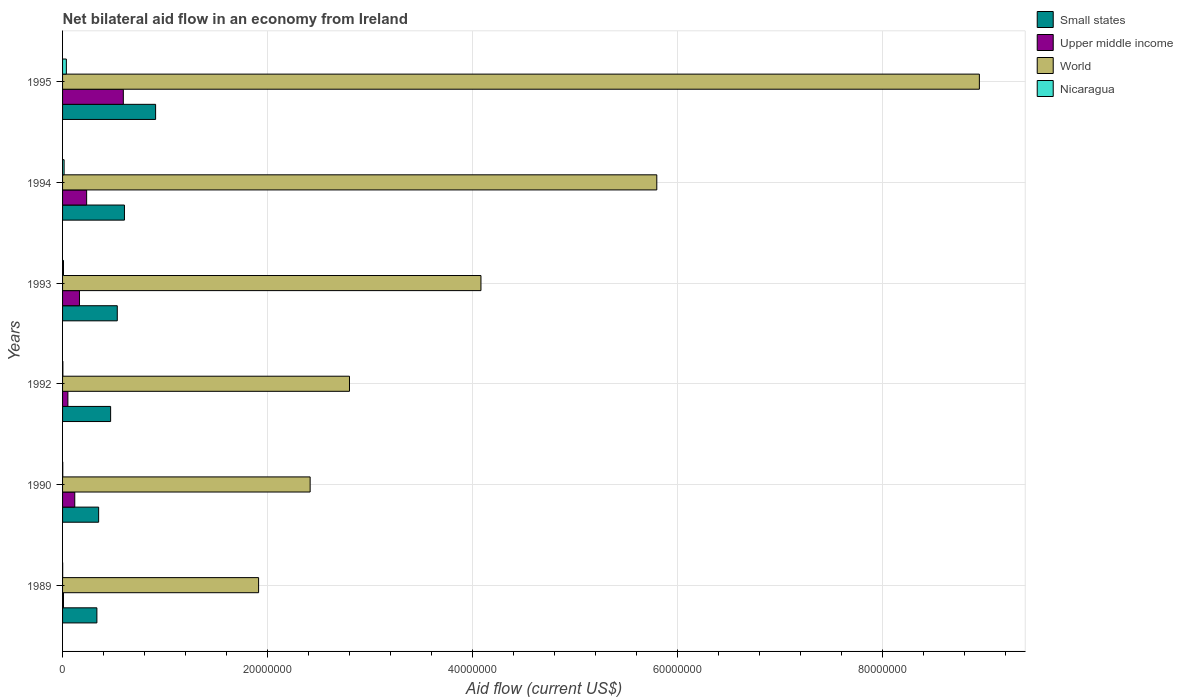Are the number of bars per tick equal to the number of legend labels?
Your answer should be very brief. Yes. Are the number of bars on each tick of the Y-axis equal?
Offer a very short reply. Yes. What is the net bilateral aid flow in Small states in 1992?
Provide a succinct answer. 4.69e+06. Across all years, what is the maximum net bilateral aid flow in Nicaragua?
Your response must be concise. 3.70e+05. Across all years, what is the minimum net bilateral aid flow in Nicaragua?
Ensure brevity in your answer.  10000. In which year was the net bilateral aid flow in Small states maximum?
Your answer should be very brief. 1995. What is the total net bilateral aid flow in World in the graph?
Provide a short and direct response. 2.60e+08. What is the difference between the net bilateral aid flow in World in 1989 and that in 1995?
Ensure brevity in your answer.  -7.03e+07. What is the difference between the net bilateral aid flow in Upper middle income in 1993 and the net bilateral aid flow in World in 1995?
Provide a succinct answer. -8.78e+07. What is the average net bilateral aid flow in Small states per year?
Ensure brevity in your answer.  5.34e+06. In the year 1989, what is the difference between the net bilateral aid flow in Upper middle income and net bilateral aid flow in Small states?
Offer a terse response. -3.26e+06. What is the ratio of the net bilateral aid flow in World in 1990 to that in 1995?
Provide a short and direct response. 0.27. Is the net bilateral aid flow in Nicaragua in 1990 less than that in 1994?
Your answer should be compact. Yes. Is the difference between the net bilateral aid flow in Upper middle income in 1992 and 1993 greater than the difference between the net bilateral aid flow in Small states in 1992 and 1993?
Your answer should be very brief. No. What is the difference between the highest and the second highest net bilateral aid flow in Small states?
Keep it short and to the point. 3.04e+06. What is the difference between the highest and the lowest net bilateral aid flow in Upper middle income?
Offer a terse response. 5.84e+06. Is the sum of the net bilateral aid flow in Small states in 1989 and 1993 greater than the maximum net bilateral aid flow in Nicaragua across all years?
Keep it short and to the point. Yes. What does the 4th bar from the top in 1989 represents?
Keep it short and to the point. Small states. What does the 2nd bar from the bottom in 1995 represents?
Offer a terse response. Upper middle income. Is it the case that in every year, the sum of the net bilateral aid flow in Nicaragua and net bilateral aid flow in Upper middle income is greater than the net bilateral aid flow in Small states?
Ensure brevity in your answer.  No. How many years are there in the graph?
Your answer should be very brief. 6. What is the difference between two consecutive major ticks on the X-axis?
Provide a succinct answer. 2.00e+07. Are the values on the major ticks of X-axis written in scientific E-notation?
Your answer should be compact. No. How are the legend labels stacked?
Offer a terse response. Vertical. What is the title of the graph?
Provide a succinct answer. Net bilateral aid flow in an economy from Ireland. Does "Nepal" appear as one of the legend labels in the graph?
Your answer should be compact. No. What is the label or title of the Y-axis?
Offer a very short reply. Years. What is the Aid flow (current US$) of Small states in 1989?
Your answer should be compact. 3.35e+06. What is the Aid flow (current US$) in Upper middle income in 1989?
Your answer should be very brief. 9.00e+04. What is the Aid flow (current US$) of World in 1989?
Your response must be concise. 1.91e+07. What is the Aid flow (current US$) of Nicaragua in 1989?
Provide a short and direct response. 10000. What is the Aid flow (current US$) of Small states in 1990?
Provide a succinct answer. 3.52e+06. What is the Aid flow (current US$) in Upper middle income in 1990?
Your answer should be very brief. 1.19e+06. What is the Aid flow (current US$) of World in 1990?
Your response must be concise. 2.42e+07. What is the Aid flow (current US$) of Nicaragua in 1990?
Offer a very short reply. 2.00e+04. What is the Aid flow (current US$) in Small states in 1992?
Your response must be concise. 4.69e+06. What is the Aid flow (current US$) of Upper middle income in 1992?
Ensure brevity in your answer.  5.20e+05. What is the Aid flow (current US$) of World in 1992?
Offer a terse response. 2.80e+07. What is the Aid flow (current US$) of Small states in 1993?
Offer a terse response. 5.34e+06. What is the Aid flow (current US$) in Upper middle income in 1993?
Offer a terse response. 1.65e+06. What is the Aid flow (current US$) of World in 1993?
Offer a terse response. 4.08e+07. What is the Aid flow (current US$) of Nicaragua in 1993?
Provide a short and direct response. 9.00e+04. What is the Aid flow (current US$) of Small states in 1994?
Offer a terse response. 6.04e+06. What is the Aid flow (current US$) in Upper middle income in 1994?
Offer a terse response. 2.35e+06. What is the Aid flow (current US$) in World in 1994?
Provide a succinct answer. 5.80e+07. What is the Aid flow (current US$) of Small states in 1995?
Provide a succinct answer. 9.08e+06. What is the Aid flow (current US$) in Upper middle income in 1995?
Your answer should be very brief. 5.93e+06. What is the Aid flow (current US$) of World in 1995?
Ensure brevity in your answer.  8.95e+07. What is the Aid flow (current US$) of Nicaragua in 1995?
Ensure brevity in your answer.  3.70e+05. Across all years, what is the maximum Aid flow (current US$) of Small states?
Provide a succinct answer. 9.08e+06. Across all years, what is the maximum Aid flow (current US$) of Upper middle income?
Provide a succinct answer. 5.93e+06. Across all years, what is the maximum Aid flow (current US$) of World?
Offer a terse response. 8.95e+07. Across all years, what is the maximum Aid flow (current US$) in Nicaragua?
Make the answer very short. 3.70e+05. Across all years, what is the minimum Aid flow (current US$) in Small states?
Keep it short and to the point. 3.35e+06. Across all years, what is the minimum Aid flow (current US$) in Upper middle income?
Ensure brevity in your answer.  9.00e+04. Across all years, what is the minimum Aid flow (current US$) in World?
Offer a terse response. 1.91e+07. What is the total Aid flow (current US$) in Small states in the graph?
Your answer should be very brief. 3.20e+07. What is the total Aid flow (current US$) of Upper middle income in the graph?
Offer a terse response. 1.17e+07. What is the total Aid flow (current US$) of World in the graph?
Provide a succinct answer. 2.60e+08. What is the total Aid flow (current US$) in Nicaragua in the graph?
Offer a very short reply. 6.70e+05. What is the difference between the Aid flow (current US$) of Small states in 1989 and that in 1990?
Offer a terse response. -1.70e+05. What is the difference between the Aid flow (current US$) in Upper middle income in 1989 and that in 1990?
Give a very brief answer. -1.10e+06. What is the difference between the Aid flow (current US$) in World in 1989 and that in 1990?
Give a very brief answer. -5.03e+06. What is the difference between the Aid flow (current US$) in Nicaragua in 1989 and that in 1990?
Offer a very short reply. -10000. What is the difference between the Aid flow (current US$) in Small states in 1989 and that in 1992?
Offer a terse response. -1.34e+06. What is the difference between the Aid flow (current US$) in Upper middle income in 1989 and that in 1992?
Provide a short and direct response. -4.30e+05. What is the difference between the Aid flow (current US$) of World in 1989 and that in 1992?
Provide a short and direct response. -8.87e+06. What is the difference between the Aid flow (current US$) in Nicaragua in 1989 and that in 1992?
Your answer should be compact. -2.00e+04. What is the difference between the Aid flow (current US$) of Small states in 1989 and that in 1993?
Provide a succinct answer. -1.99e+06. What is the difference between the Aid flow (current US$) of Upper middle income in 1989 and that in 1993?
Offer a terse response. -1.56e+06. What is the difference between the Aid flow (current US$) in World in 1989 and that in 1993?
Your answer should be compact. -2.17e+07. What is the difference between the Aid flow (current US$) in Small states in 1989 and that in 1994?
Provide a succinct answer. -2.69e+06. What is the difference between the Aid flow (current US$) of Upper middle income in 1989 and that in 1994?
Give a very brief answer. -2.26e+06. What is the difference between the Aid flow (current US$) in World in 1989 and that in 1994?
Your response must be concise. -3.89e+07. What is the difference between the Aid flow (current US$) of Nicaragua in 1989 and that in 1994?
Provide a short and direct response. -1.40e+05. What is the difference between the Aid flow (current US$) in Small states in 1989 and that in 1995?
Your answer should be compact. -5.73e+06. What is the difference between the Aid flow (current US$) in Upper middle income in 1989 and that in 1995?
Make the answer very short. -5.84e+06. What is the difference between the Aid flow (current US$) of World in 1989 and that in 1995?
Ensure brevity in your answer.  -7.03e+07. What is the difference between the Aid flow (current US$) in Nicaragua in 1989 and that in 1995?
Make the answer very short. -3.60e+05. What is the difference between the Aid flow (current US$) of Small states in 1990 and that in 1992?
Your answer should be very brief. -1.17e+06. What is the difference between the Aid flow (current US$) in Upper middle income in 1990 and that in 1992?
Give a very brief answer. 6.70e+05. What is the difference between the Aid flow (current US$) of World in 1990 and that in 1992?
Make the answer very short. -3.84e+06. What is the difference between the Aid flow (current US$) in Nicaragua in 1990 and that in 1992?
Your answer should be compact. -10000. What is the difference between the Aid flow (current US$) in Small states in 1990 and that in 1993?
Ensure brevity in your answer.  -1.82e+06. What is the difference between the Aid flow (current US$) of Upper middle income in 1990 and that in 1993?
Provide a succinct answer. -4.60e+05. What is the difference between the Aid flow (current US$) of World in 1990 and that in 1993?
Provide a succinct answer. -1.67e+07. What is the difference between the Aid flow (current US$) of Nicaragua in 1990 and that in 1993?
Your response must be concise. -7.00e+04. What is the difference between the Aid flow (current US$) in Small states in 1990 and that in 1994?
Offer a terse response. -2.52e+06. What is the difference between the Aid flow (current US$) in Upper middle income in 1990 and that in 1994?
Provide a short and direct response. -1.16e+06. What is the difference between the Aid flow (current US$) in World in 1990 and that in 1994?
Provide a short and direct response. -3.38e+07. What is the difference between the Aid flow (current US$) of Small states in 1990 and that in 1995?
Offer a very short reply. -5.56e+06. What is the difference between the Aid flow (current US$) of Upper middle income in 1990 and that in 1995?
Ensure brevity in your answer.  -4.74e+06. What is the difference between the Aid flow (current US$) in World in 1990 and that in 1995?
Offer a very short reply. -6.53e+07. What is the difference between the Aid flow (current US$) in Nicaragua in 1990 and that in 1995?
Offer a very short reply. -3.50e+05. What is the difference between the Aid flow (current US$) in Small states in 1992 and that in 1993?
Ensure brevity in your answer.  -6.50e+05. What is the difference between the Aid flow (current US$) in Upper middle income in 1992 and that in 1993?
Provide a succinct answer. -1.13e+06. What is the difference between the Aid flow (current US$) of World in 1992 and that in 1993?
Ensure brevity in your answer.  -1.28e+07. What is the difference between the Aid flow (current US$) of Small states in 1992 and that in 1994?
Offer a terse response. -1.35e+06. What is the difference between the Aid flow (current US$) in Upper middle income in 1992 and that in 1994?
Your response must be concise. -1.83e+06. What is the difference between the Aid flow (current US$) in World in 1992 and that in 1994?
Give a very brief answer. -3.00e+07. What is the difference between the Aid flow (current US$) in Small states in 1992 and that in 1995?
Keep it short and to the point. -4.39e+06. What is the difference between the Aid flow (current US$) in Upper middle income in 1992 and that in 1995?
Offer a very short reply. -5.41e+06. What is the difference between the Aid flow (current US$) of World in 1992 and that in 1995?
Ensure brevity in your answer.  -6.15e+07. What is the difference between the Aid flow (current US$) of Nicaragua in 1992 and that in 1995?
Provide a succinct answer. -3.40e+05. What is the difference between the Aid flow (current US$) in Small states in 1993 and that in 1994?
Your answer should be compact. -7.00e+05. What is the difference between the Aid flow (current US$) of Upper middle income in 1993 and that in 1994?
Ensure brevity in your answer.  -7.00e+05. What is the difference between the Aid flow (current US$) of World in 1993 and that in 1994?
Offer a very short reply. -1.72e+07. What is the difference between the Aid flow (current US$) in Small states in 1993 and that in 1995?
Offer a terse response. -3.74e+06. What is the difference between the Aid flow (current US$) of Upper middle income in 1993 and that in 1995?
Provide a short and direct response. -4.28e+06. What is the difference between the Aid flow (current US$) of World in 1993 and that in 1995?
Keep it short and to the point. -4.86e+07. What is the difference between the Aid flow (current US$) in Nicaragua in 1993 and that in 1995?
Make the answer very short. -2.80e+05. What is the difference between the Aid flow (current US$) in Small states in 1994 and that in 1995?
Offer a terse response. -3.04e+06. What is the difference between the Aid flow (current US$) in Upper middle income in 1994 and that in 1995?
Provide a succinct answer. -3.58e+06. What is the difference between the Aid flow (current US$) in World in 1994 and that in 1995?
Give a very brief answer. -3.15e+07. What is the difference between the Aid flow (current US$) of Small states in 1989 and the Aid flow (current US$) of Upper middle income in 1990?
Ensure brevity in your answer.  2.16e+06. What is the difference between the Aid flow (current US$) of Small states in 1989 and the Aid flow (current US$) of World in 1990?
Provide a short and direct response. -2.08e+07. What is the difference between the Aid flow (current US$) in Small states in 1989 and the Aid flow (current US$) in Nicaragua in 1990?
Provide a succinct answer. 3.33e+06. What is the difference between the Aid flow (current US$) in Upper middle income in 1989 and the Aid flow (current US$) in World in 1990?
Offer a very short reply. -2.41e+07. What is the difference between the Aid flow (current US$) in Upper middle income in 1989 and the Aid flow (current US$) in Nicaragua in 1990?
Your answer should be very brief. 7.00e+04. What is the difference between the Aid flow (current US$) of World in 1989 and the Aid flow (current US$) of Nicaragua in 1990?
Your answer should be compact. 1.91e+07. What is the difference between the Aid flow (current US$) in Small states in 1989 and the Aid flow (current US$) in Upper middle income in 1992?
Your response must be concise. 2.83e+06. What is the difference between the Aid flow (current US$) of Small states in 1989 and the Aid flow (current US$) of World in 1992?
Your answer should be compact. -2.46e+07. What is the difference between the Aid flow (current US$) of Small states in 1989 and the Aid flow (current US$) of Nicaragua in 1992?
Your response must be concise. 3.32e+06. What is the difference between the Aid flow (current US$) in Upper middle income in 1989 and the Aid flow (current US$) in World in 1992?
Offer a terse response. -2.79e+07. What is the difference between the Aid flow (current US$) of Upper middle income in 1989 and the Aid flow (current US$) of Nicaragua in 1992?
Offer a terse response. 6.00e+04. What is the difference between the Aid flow (current US$) of World in 1989 and the Aid flow (current US$) of Nicaragua in 1992?
Your answer should be very brief. 1.91e+07. What is the difference between the Aid flow (current US$) of Small states in 1989 and the Aid flow (current US$) of Upper middle income in 1993?
Offer a very short reply. 1.70e+06. What is the difference between the Aid flow (current US$) in Small states in 1989 and the Aid flow (current US$) in World in 1993?
Make the answer very short. -3.75e+07. What is the difference between the Aid flow (current US$) in Small states in 1989 and the Aid flow (current US$) in Nicaragua in 1993?
Keep it short and to the point. 3.26e+06. What is the difference between the Aid flow (current US$) of Upper middle income in 1989 and the Aid flow (current US$) of World in 1993?
Give a very brief answer. -4.07e+07. What is the difference between the Aid flow (current US$) in World in 1989 and the Aid flow (current US$) in Nicaragua in 1993?
Offer a terse response. 1.90e+07. What is the difference between the Aid flow (current US$) of Small states in 1989 and the Aid flow (current US$) of Upper middle income in 1994?
Keep it short and to the point. 1.00e+06. What is the difference between the Aid flow (current US$) in Small states in 1989 and the Aid flow (current US$) in World in 1994?
Offer a very short reply. -5.46e+07. What is the difference between the Aid flow (current US$) in Small states in 1989 and the Aid flow (current US$) in Nicaragua in 1994?
Provide a succinct answer. 3.20e+06. What is the difference between the Aid flow (current US$) of Upper middle income in 1989 and the Aid flow (current US$) of World in 1994?
Provide a short and direct response. -5.79e+07. What is the difference between the Aid flow (current US$) in Upper middle income in 1989 and the Aid flow (current US$) in Nicaragua in 1994?
Offer a terse response. -6.00e+04. What is the difference between the Aid flow (current US$) of World in 1989 and the Aid flow (current US$) of Nicaragua in 1994?
Your answer should be very brief. 1.90e+07. What is the difference between the Aid flow (current US$) in Small states in 1989 and the Aid flow (current US$) in Upper middle income in 1995?
Offer a very short reply. -2.58e+06. What is the difference between the Aid flow (current US$) in Small states in 1989 and the Aid flow (current US$) in World in 1995?
Offer a terse response. -8.61e+07. What is the difference between the Aid flow (current US$) in Small states in 1989 and the Aid flow (current US$) in Nicaragua in 1995?
Keep it short and to the point. 2.98e+06. What is the difference between the Aid flow (current US$) of Upper middle income in 1989 and the Aid flow (current US$) of World in 1995?
Make the answer very short. -8.94e+07. What is the difference between the Aid flow (current US$) in Upper middle income in 1989 and the Aid flow (current US$) in Nicaragua in 1995?
Your answer should be compact. -2.80e+05. What is the difference between the Aid flow (current US$) in World in 1989 and the Aid flow (current US$) in Nicaragua in 1995?
Make the answer very short. 1.88e+07. What is the difference between the Aid flow (current US$) in Small states in 1990 and the Aid flow (current US$) in World in 1992?
Provide a succinct answer. -2.45e+07. What is the difference between the Aid flow (current US$) in Small states in 1990 and the Aid flow (current US$) in Nicaragua in 1992?
Your answer should be very brief. 3.49e+06. What is the difference between the Aid flow (current US$) of Upper middle income in 1990 and the Aid flow (current US$) of World in 1992?
Offer a terse response. -2.68e+07. What is the difference between the Aid flow (current US$) in Upper middle income in 1990 and the Aid flow (current US$) in Nicaragua in 1992?
Give a very brief answer. 1.16e+06. What is the difference between the Aid flow (current US$) of World in 1990 and the Aid flow (current US$) of Nicaragua in 1992?
Offer a very short reply. 2.41e+07. What is the difference between the Aid flow (current US$) of Small states in 1990 and the Aid flow (current US$) of Upper middle income in 1993?
Your answer should be compact. 1.87e+06. What is the difference between the Aid flow (current US$) of Small states in 1990 and the Aid flow (current US$) of World in 1993?
Your answer should be compact. -3.73e+07. What is the difference between the Aid flow (current US$) in Small states in 1990 and the Aid flow (current US$) in Nicaragua in 1993?
Provide a succinct answer. 3.43e+06. What is the difference between the Aid flow (current US$) in Upper middle income in 1990 and the Aid flow (current US$) in World in 1993?
Ensure brevity in your answer.  -3.96e+07. What is the difference between the Aid flow (current US$) of Upper middle income in 1990 and the Aid flow (current US$) of Nicaragua in 1993?
Provide a short and direct response. 1.10e+06. What is the difference between the Aid flow (current US$) of World in 1990 and the Aid flow (current US$) of Nicaragua in 1993?
Your answer should be compact. 2.41e+07. What is the difference between the Aid flow (current US$) of Small states in 1990 and the Aid flow (current US$) of Upper middle income in 1994?
Offer a very short reply. 1.17e+06. What is the difference between the Aid flow (current US$) of Small states in 1990 and the Aid flow (current US$) of World in 1994?
Offer a very short reply. -5.45e+07. What is the difference between the Aid flow (current US$) of Small states in 1990 and the Aid flow (current US$) of Nicaragua in 1994?
Your answer should be compact. 3.37e+06. What is the difference between the Aid flow (current US$) in Upper middle income in 1990 and the Aid flow (current US$) in World in 1994?
Give a very brief answer. -5.68e+07. What is the difference between the Aid flow (current US$) of Upper middle income in 1990 and the Aid flow (current US$) of Nicaragua in 1994?
Ensure brevity in your answer.  1.04e+06. What is the difference between the Aid flow (current US$) of World in 1990 and the Aid flow (current US$) of Nicaragua in 1994?
Offer a very short reply. 2.40e+07. What is the difference between the Aid flow (current US$) of Small states in 1990 and the Aid flow (current US$) of Upper middle income in 1995?
Provide a short and direct response. -2.41e+06. What is the difference between the Aid flow (current US$) in Small states in 1990 and the Aid flow (current US$) in World in 1995?
Your answer should be compact. -8.60e+07. What is the difference between the Aid flow (current US$) in Small states in 1990 and the Aid flow (current US$) in Nicaragua in 1995?
Keep it short and to the point. 3.15e+06. What is the difference between the Aid flow (current US$) of Upper middle income in 1990 and the Aid flow (current US$) of World in 1995?
Ensure brevity in your answer.  -8.83e+07. What is the difference between the Aid flow (current US$) in Upper middle income in 1990 and the Aid flow (current US$) in Nicaragua in 1995?
Keep it short and to the point. 8.20e+05. What is the difference between the Aid flow (current US$) in World in 1990 and the Aid flow (current US$) in Nicaragua in 1995?
Provide a succinct answer. 2.38e+07. What is the difference between the Aid flow (current US$) in Small states in 1992 and the Aid flow (current US$) in Upper middle income in 1993?
Offer a very short reply. 3.04e+06. What is the difference between the Aid flow (current US$) of Small states in 1992 and the Aid flow (current US$) of World in 1993?
Your answer should be compact. -3.61e+07. What is the difference between the Aid flow (current US$) in Small states in 1992 and the Aid flow (current US$) in Nicaragua in 1993?
Provide a short and direct response. 4.60e+06. What is the difference between the Aid flow (current US$) in Upper middle income in 1992 and the Aid flow (current US$) in World in 1993?
Ensure brevity in your answer.  -4.03e+07. What is the difference between the Aid flow (current US$) of Upper middle income in 1992 and the Aid flow (current US$) of Nicaragua in 1993?
Your answer should be compact. 4.30e+05. What is the difference between the Aid flow (current US$) in World in 1992 and the Aid flow (current US$) in Nicaragua in 1993?
Your answer should be compact. 2.79e+07. What is the difference between the Aid flow (current US$) of Small states in 1992 and the Aid flow (current US$) of Upper middle income in 1994?
Offer a terse response. 2.34e+06. What is the difference between the Aid flow (current US$) of Small states in 1992 and the Aid flow (current US$) of World in 1994?
Make the answer very short. -5.33e+07. What is the difference between the Aid flow (current US$) in Small states in 1992 and the Aid flow (current US$) in Nicaragua in 1994?
Provide a succinct answer. 4.54e+06. What is the difference between the Aid flow (current US$) of Upper middle income in 1992 and the Aid flow (current US$) of World in 1994?
Offer a terse response. -5.75e+07. What is the difference between the Aid flow (current US$) in World in 1992 and the Aid flow (current US$) in Nicaragua in 1994?
Your response must be concise. 2.78e+07. What is the difference between the Aid flow (current US$) in Small states in 1992 and the Aid flow (current US$) in Upper middle income in 1995?
Provide a short and direct response. -1.24e+06. What is the difference between the Aid flow (current US$) in Small states in 1992 and the Aid flow (current US$) in World in 1995?
Your answer should be very brief. -8.48e+07. What is the difference between the Aid flow (current US$) in Small states in 1992 and the Aid flow (current US$) in Nicaragua in 1995?
Keep it short and to the point. 4.32e+06. What is the difference between the Aid flow (current US$) of Upper middle income in 1992 and the Aid flow (current US$) of World in 1995?
Give a very brief answer. -8.90e+07. What is the difference between the Aid flow (current US$) of World in 1992 and the Aid flow (current US$) of Nicaragua in 1995?
Provide a succinct answer. 2.76e+07. What is the difference between the Aid flow (current US$) in Small states in 1993 and the Aid flow (current US$) in Upper middle income in 1994?
Make the answer very short. 2.99e+06. What is the difference between the Aid flow (current US$) of Small states in 1993 and the Aid flow (current US$) of World in 1994?
Your answer should be compact. -5.26e+07. What is the difference between the Aid flow (current US$) of Small states in 1993 and the Aid flow (current US$) of Nicaragua in 1994?
Make the answer very short. 5.19e+06. What is the difference between the Aid flow (current US$) of Upper middle income in 1993 and the Aid flow (current US$) of World in 1994?
Give a very brief answer. -5.63e+07. What is the difference between the Aid flow (current US$) in Upper middle income in 1993 and the Aid flow (current US$) in Nicaragua in 1994?
Give a very brief answer. 1.50e+06. What is the difference between the Aid flow (current US$) in World in 1993 and the Aid flow (current US$) in Nicaragua in 1994?
Make the answer very short. 4.07e+07. What is the difference between the Aid flow (current US$) of Small states in 1993 and the Aid flow (current US$) of Upper middle income in 1995?
Your response must be concise. -5.90e+05. What is the difference between the Aid flow (current US$) of Small states in 1993 and the Aid flow (current US$) of World in 1995?
Make the answer very short. -8.41e+07. What is the difference between the Aid flow (current US$) of Small states in 1993 and the Aid flow (current US$) of Nicaragua in 1995?
Provide a succinct answer. 4.97e+06. What is the difference between the Aid flow (current US$) of Upper middle income in 1993 and the Aid flow (current US$) of World in 1995?
Offer a terse response. -8.78e+07. What is the difference between the Aid flow (current US$) in Upper middle income in 1993 and the Aid flow (current US$) in Nicaragua in 1995?
Offer a terse response. 1.28e+06. What is the difference between the Aid flow (current US$) of World in 1993 and the Aid flow (current US$) of Nicaragua in 1995?
Provide a succinct answer. 4.05e+07. What is the difference between the Aid flow (current US$) of Small states in 1994 and the Aid flow (current US$) of Upper middle income in 1995?
Provide a short and direct response. 1.10e+05. What is the difference between the Aid flow (current US$) in Small states in 1994 and the Aid flow (current US$) in World in 1995?
Provide a short and direct response. -8.34e+07. What is the difference between the Aid flow (current US$) of Small states in 1994 and the Aid flow (current US$) of Nicaragua in 1995?
Offer a very short reply. 5.67e+06. What is the difference between the Aid flow (current US$) in Upper middle income in 1994 and the Aid flow (current US$) in World in 1995?
Make the answer very short. -8.71e+07. What is the difference between the Aid flow (current US$) of Upper middle income in 1994 and the Aid flow (current US$) of Nicaragua in 1995?
Your response must be concise. 1.98e+06. What is the difference between the Aid flow (current US$) in World in 1994 and the Aid flow (current US$) in Nicaragua in 1995?
Keep it short and to the point. 5.76e+07. What is the average Aid flow (current US$) of Small states per year?
Your answer should be very brief. 5.34e+06. What is the average Aid flow (current US$) of Upper middle income per year?
Your answer should be compact. 1.96e+06. What is the average Aid flow (current US$) in World per year?
Make the answer very short. 4.33e+07. What is the average Aid flow (current US$) in Nicaragua per year?
Provide a succinct answer. 1.12e+05. In the year 1989, what is the difference between the Aid flow (current US$) of Small states and Aid flow (current US$) of Upper middle income?
Make the answer very short. 3.26e+06. In the year 1989, what is the difference between the Aid flow (current US$) in Small states and Aid flow (current US$) in World?
Ensure brevity in your answer.  -1.58e+07. In the year 1989, what is the difference between the Aid flow (current US$) of Small states and Aid flow (current US$) of Nicaragua?
Make the answer very short. 3.34e+06. In the year 1989, what is the difference between the Aid flow (current US$) of Upper middle income and Aid flow (current US$) of World?
Provide a short and direct response. -1.90e+07. In the year 1989, what is the difference between the Aid flow (current US$) of World and Aid flow (current US$) of Nicaragua?
Provide a succinct answer. 1.91e+07. In the year 1990, what is the difference between the Aid flow (current US$) of Small states and Aid flow (current US$) of Upper middle income?
Make the answer very short. 2.33e+06. In the year 1990, what is the difference between the Aid flow (current US$) of Small states and Aid flow (current US$) of World?
Provide a succinct answer. -2.06e+07. In the year 1990, what is the difference between the Aid flow (current US$) in Small states and Aid flow (current US$) in Nicaragua?
Your response must be concise. 3.50e+06. In the year 1990, what is the difference between the Aid flow (current US$) in Upper middle income and Aid flow (current US$) in World?
Your answer should be compact. -2.30e+07. In the year 1990, what is the difference between the Aid flow (current US$) of Upper middle income and Aid flow (current US$) of Nicaragua?
Your answer should be very brief. 1.17e+06. In the year 1990, what is the difference between the Aid flow (current US$) of World and Aid flow (current US$) of Nicaragua?
Make the answer very short. 2.41e+07. In the year 1992, what is the difference between the Aid flow (current US$) of Small states and Aid flow (current US$) of Upper middle income?
Keep it short and to the point. 4.17e+06. In the year 1992, what is the difference between the Aid flow (current US$) in Small states and Aid flow (current US$) in World?
Offer a terse response. -2.33e+07. In the year 1992, what is the difference between the Aid flow (current US$) in Small states and Aid flow (current US$) in Nicaragua?
Your response must be concise. 4.66e+06. In the year 1992, what is the difference between the Aid flow (current US$) of Upper middle income and Aid flow (current US$) of World?
Your response must be concise. -2.75e+07. In the year 1992, what is the difference between the Aid flow (current US$) in Upper middle income and Aid flow (current US$) in Nicaragua?
Offer a terse response. 4.90e+05. In the year 1992, what is the difference between the Aid flow (current US$) of World and Aid flow (current US$) of Nicaragua?
Keep it short and to the point. 2.80e+07. In the year 1993, what is the difference between the Aid flow (current US$) in Small states and Aid flow (current US$) in Upper middle income?
Ensure brevity in your answer.  3.69e+06. In the year 1993, what is the difference between the Aid flow (current US$) of Small states and Aid flow (current US$) of World?
Offer a terse response. -3.55e+07. In the year 1993, what is the difference between the Aid flow (current US$) in Small states and Aid flow (current US$) in Nicaragua?
Your answer should be very brief. 5.25e+06. In the year 1993, what is the difference between the Aid flow (current US$) of Upper middle income and Aid flow (current US$) of World?
Make the answer very short. -3.92e+07. In the year 1993, what is the difference between the Aid flow (current US$) of Upper middle income and Aid flow (current US$) of Nicaragua?
Make the answer very short. 1.56e+06. In the year 1993, what is the difference between the Aid flow (current US$) in World and Aid flow (current US$) in Nicaragua?
Offer a terse response. 4.07e+07. In the year 1994, what is the difference between the Aid flow (current US$) in Small states and Aid flow (current US$) in Upper middle income?
Provide a short and direct response. 3.69e+06. In the year 1994, what is the difference between the Aid flow (current US$) of Small states and Aid flow (current US$) of World?
Offer a terse response. -5.20e+07. In the year 1994, what is the difference between the Aid flow (current US$) in Small states and Aid flow (current US$) in Nicaragua?
Your response must be concise. 5.89e+06. In the year 1994, what is the difference between the Aid flow (current US$) of Upper middle income and Aid flow (current US$) of World?
Provide a succinct answer. -5.56e+07. In the year 1994, what is the difference between the Aid flow (current US$) of Upper middle income and Aid flow (current US$) of Nicaragua?
Ensure brevity in your answer.  2.20e+06. In the year 1994, what is the difference between the Aid flow (current US$) in World and Aid flow (current US$) in Nicaragua?
Make the answer very short. 5.78e+07. In the year 1995, what is the difference between the Aid flow (current US$) in Small states and Aid flow (current US$) in Upper middle income?
Offer a very short reply. 3.15e+06. In the year 1995, what is the difference between the Aid flow (current US$) of Small states and Aid flow (current US$) of World?
Give a very brief answer. -8.04e+07. In the year 1995, what is the difference between the Aid flow (current US$) in Small states and Aid flow (current US$) in Nicaragua?
Make the answer very short. 8.71e+06. In the year 1995, what is the difference between the Aid flow (current US$) of Upper middle income and Aid flow (current US$) of World?
Provide a succinct answer. -8.35e+07. In the year 1995, what is the difference between the Aid flow (current US$) in Upper middle income and Aid flow (current US$) in Nicaragua?
Provide a short and direct response. 5.56e+06. In the year 1995, what is the difference between the Aid flow (current US$) in World and Aid flow (current US$) in Nicaragua?
Make the answer very short. 8.91e+07. What is the ratio of the Aid flow (current US$) in Small states in 1989 to that in 1990?
Ensure brevity in your answer.  0.95. What is the ratio of the Aid flow (current US$) in Upper middle income in 1989 to that in 1990?
Keep it short and to the point. 0.08. What is the ratio of the Aid flow (current US$) of World in 1989 to that in 1990?
Offer a terse response. 0.79. What is the ratio of the Aid flow (current US$) of Small states in 1989 to that in 1992?
Your answer should be very brief. 0.71. What is the ratio of the Aid flow (current US$) in Upper middle income in 1989 to that in 1992?
Provide a short and direct response. 0.17. What is the ratio of the Aid flow (current US$) of World in 1989 to that in 1992?
Give a very brief answer. 0.68. What is the ratio of the Aid flow (current US$) of Small states in 1989 to that in 1993?
Give a very brief answer. 0.63. What is the ratio of the Aid flow (current US$) in Upper middle income in 1989 to that in 1993?
Offer a very short reply. 0.05. What is the ratio of the Aid flow (current US$) of World in 1989 to that in 1993?
Your answer should be compact. 0.47. What is the ratio of the Aid flow (current US$) in Nicaragua in 1989 to that in 1993?
Keep it short and to the point. 0.11. What is the ratio of the Aid flow (current US$) of Small states in 1989 to that in 1994?
Give a very brief answer. 0.55. What is the ratio of the Aid flow (current US$) of Upper middle income in 1989 to that in 1994?
Your answer should be very brief. 0.04. What is the ratio of the Aid flow (current US$) in World in 1989 to that in 1994?
Keep it short and to the point. 0.33. What is the ratio of the Aid flow (current US$) of Nicaragua in 1989 to that in 1994?
Ensure brevity in your answer.  0.07. What is the ratio of the Aid flow (current US$) of Small states in 1989 to that in 1995?
Your response must be concise. 0.37. What is the ratio of the Aid flow (current US$) of Upper middle income in 1989 to that in 1995?
Your answer should be compact. 0.02. What is the ratio of the Aid flow (current US$) in World in 1989 to that in 1995?
Your answer should be compact. 0.21. What is the ratio of the Aid flow (current US$) in Nicaragua in 1989 to that in 1995?
Ensure brevity in your answer.  0.03. What is the ratio of the Aid flow (current US$) in Small states in 1990 to that in 1992?
Provide a short and direct response. 0.75. What is the ratio of the Aid flow (current US$) in Upper middle income in 1990 to that in 1992?
Offer a very short reply. 2.29. What is the ratio of the Aid flow (current US$) in World in 1990 to that in 1992?
Give a very brief answer. 0.86. What is the ratio of the Aid flow (current US$) in Nicaragua in 1990 to that in 1992?
Make the answer very short. 0.67. What is the ratio of the Aid flow (current US$) in Small states in 1990 to that in 1993?
Your answer should be compact. 0.66. What is the ratio of the Aid flow (current US$) of Upper middle income in 1990 to that in 1993?
Provide a succinct answer. 0.72. What is the ratio of the Aid flow (current US$) of World in 1990 to that in 1993?
Your answer should be compact. 0.59. What is the ratio of the Aid flow (current US$) of Nicaragua in 1990 to that in 1993?
Your answer should be compact. 0.22. What is the ratio of the Aid flow (current US$) of Small states in 1990 to that in 1994?
Offer a terse response. 0.58. What is the ratio of the Aid flow (current US$) in Upper middle income in 1990 to that in 1994?
Keep it short and to the point. 0.51. What is the ratio of the Aid flow (current US$) of World in 1990 to that in 1994?
Make the answer very short. 0.42. What is the ratio of the Aid flow (current US$) in Nicaragua in 1990 to that in 1994?
Your answer should be very brief. 0.13. What is the ratio of the Aid flow (current US$) of Small states in 1990 to that in 1995?
Provide a succinct answer. 0.39. What is the ratio of the Aid flow (current US$) in Upper middle income in 1990 to that in 1995?
Keep it short and to the point. 0.2. What is the ratio of the Aid flow (current US$) in World in 1990 to that in 1995?
Give a very brief answer. 0.27. What is the ratio of the Aid flow (current US$) in Nicaragua in 1990 to that in 1995?
Offer a very short reply. 0.05. What is the ratio of the Aid flow (current US$) in Small states in 1992 to that in 1993?
Your answer should be very brief. 0.88. What is the ratio of the Aid flow (current US$) of Upper middle income in 1992 to that in 1993?
Keep it short and to the point. 0.32. What is the ratio of the Aid flow (current US$) of World in 1992 to that in 1993?
Offer a very short reply. 0.69. What is the ratio of the Aid flow (current US$) of Nicaragua in 1992 to that in 1993?
Keep it short and to the point. 0.33. What is the ratio of the Aid flow (current US$) in Small states in 1992 to that in 1994?
Your response must be concise. 0.78. What is the ratio of the Aid flow (current US$) of Upper middle income in 1992 to that in 1994?
Your answer should be compact. 0.22. What is the ratio of the Aid flow (current US$) in World in 1992 to that in 1994?
Offer a very short reply. 0.48. What is the ratio of the Aid flow (current US$) in Small states in 1992 to that in 1995?
Provide a succinct answer. 0.52. What is the ratio of the Aid flow (current US$) in Upper middle income in 1992 to that in 1995?
Your response must be concise. 0.09. What is the ratio of the Aid flow (current US$) of World in 1992 to that in 1995?
Make the answer very short. 0.31. What is the ratio of the Aid flow (current US$) in Nicaragua in 1992 to that in 1995?
Provide a succinct answer. 0.08. What is the ratio of the Aid flow (current US$) in Small states in 1993 to that in 1994?
Keep it short and to the point. 0.88. What is the ratio of the Aid flow (current US$) in Upper middle income in 1993 to that in 1994?
Make the answer very short. 0.7. What is the ratio of the Aid flow (current US$) of World in 1993 to that in 1994?
Offer a very short reply. 0.7. What is the ratio of the Aid flow (current US$) in Small states in 1993 to that in 1995?
Your answer should be very brief. 0.59. What is the ratio of the Aid flow (current US$) of Upper middle income in 1993 to that in 1995?
Offer a terse response. 0.28. What is the ratio of the Aid flow (current US$) in World in 1993 to that in 1995?
Give a very brief answer. 0.46. What is the ratio of the Aid flow (current US$) in Nicaragua in 1993 to that in 1995?
Your answer should be compact. 0.24. What is the ratio of the Aid flow (current US$) in Small states in 1994 to that in 1995?
Keep it short and to the point. 0.67. What is the ratio of the Aid flow (current US$) in Upper middle income in 1994 to that in 1995?
Provide a succinct answer. 0.4. What is the ratio of the Aid flow (current US$) of World in 1994 to that in 1995?
Make the answer very short. 0.65. What is the ratio of the Aid flow (current US$) in Nicaragua in 1994 to that in 1995?
Your response must be concise. 0.41. What is the difference between the highest and the second highest Aid flow (current US$) of Small states?
Provide a succinct answer. 3.04e+06. What is the difference between the highest and the second highest Aid flow (current US$) in Upper middle income?
Make the answer very short. 3.58e+06. What is the difference between the highest and the second highest Aid flow (current US$) of World?
Ensure brevity in your answer.  3.15e+07. What is the difference between the highest and the second highest Aid flow (current US$) in Nicaragua?
Give a very brief answer. 2.20e+05. What is the difference between the highest and the lowest Aid flow (current US$) in Small states?
Offer a terse response. 5.73e+06. What is the difference between the highest and the lowest Aid flow (current US$) of Upper middle income?
Offer a terse response. 5.84e+06. What is the difference between the highest and the lowest Aid flow (current US$) of World?
Ensure brevity in your answer.  7.03e+07. What is the difference between the highest and the lowest Aid flow (current US$) in Nicaragua?
Your response must be concise. 3.60e+05. 